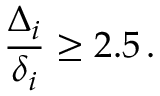Convert formula to latex. <formula><loc_0><loc_0><loc_500><loc_500>\frac { \Delta _ { i } } { \delta _ { i } } \geq 2 . 5 \, .</formula> 